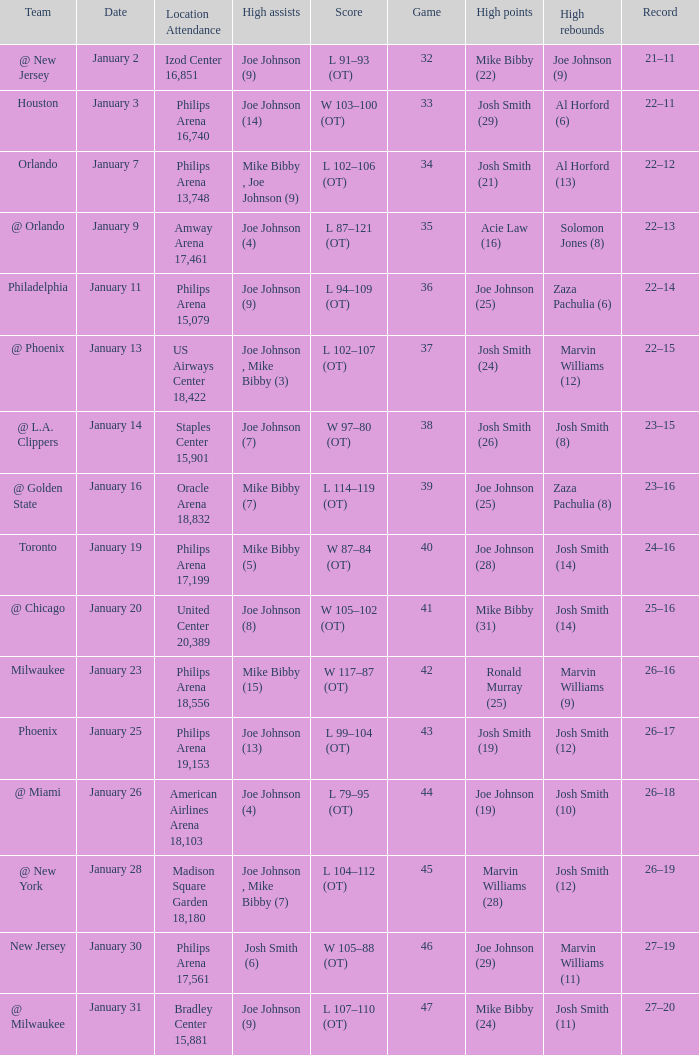Which date was game 35 on? January 9. 